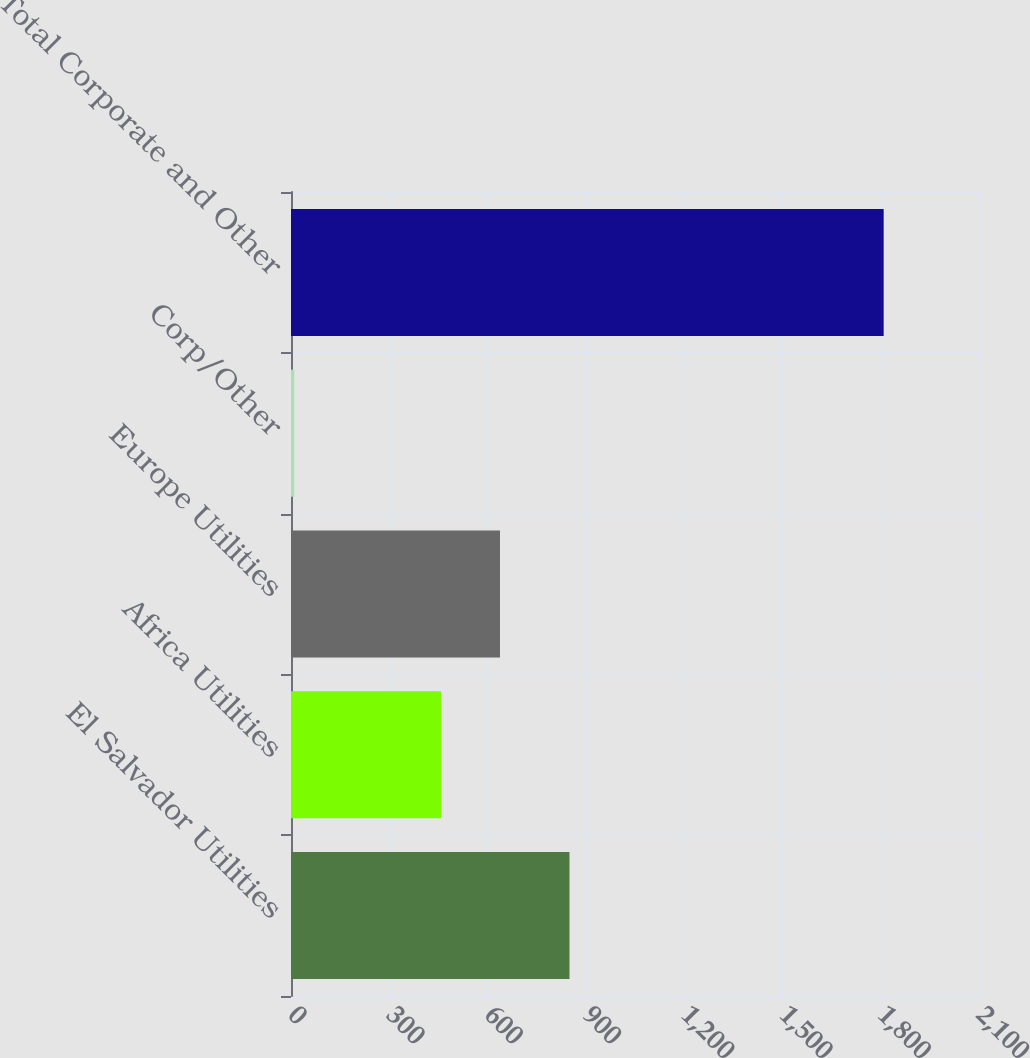<chart> <loc_0><loc_0><loc_500><loc_500><bar_chart><fcel>El Salvador Utilities<fcel>Africa Utilities<fcel>Europe Utilities<fcel>Corp/Other<fcel>Total Corporate and Other<nl><fcel>850<fcel>458<fcel>637.9<fcel>10<fcel>1809<nl></chart> 